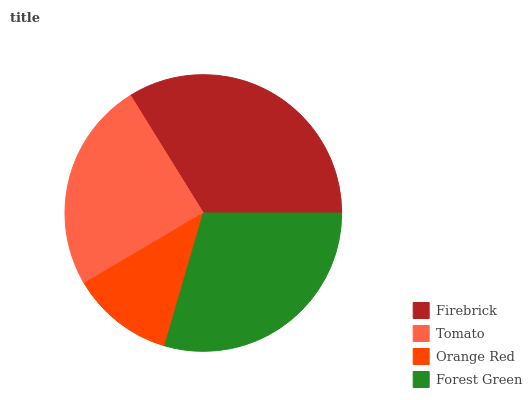Is Orange Red the minimum?
Answer yes or no. Yes. Is Firebrick the maximum?
Answer yes or no. Yes. Is Tomato the minimum?
Answer yes or no. No. Is Tomato the maximum?
Answer yes or no. No. Is Firebrick greater than Tomato?
Answer yes or no. Yes. Is Tomato less than Firebrick?
Answer yes or no. Yes. Is Tomato greater than Firebrick?
Answer yes or no. No. Is Firebrick less than Tomato?
Answer yes or no. No. Is Forest Green the high median?
Answer yes or no. Yes. Is Tomato the low median?
Answer yes or no. Yes. Is Tomato the high median?
Answer yes or no. No. Is Orange Red the low median?
Answer yes or no. No. 